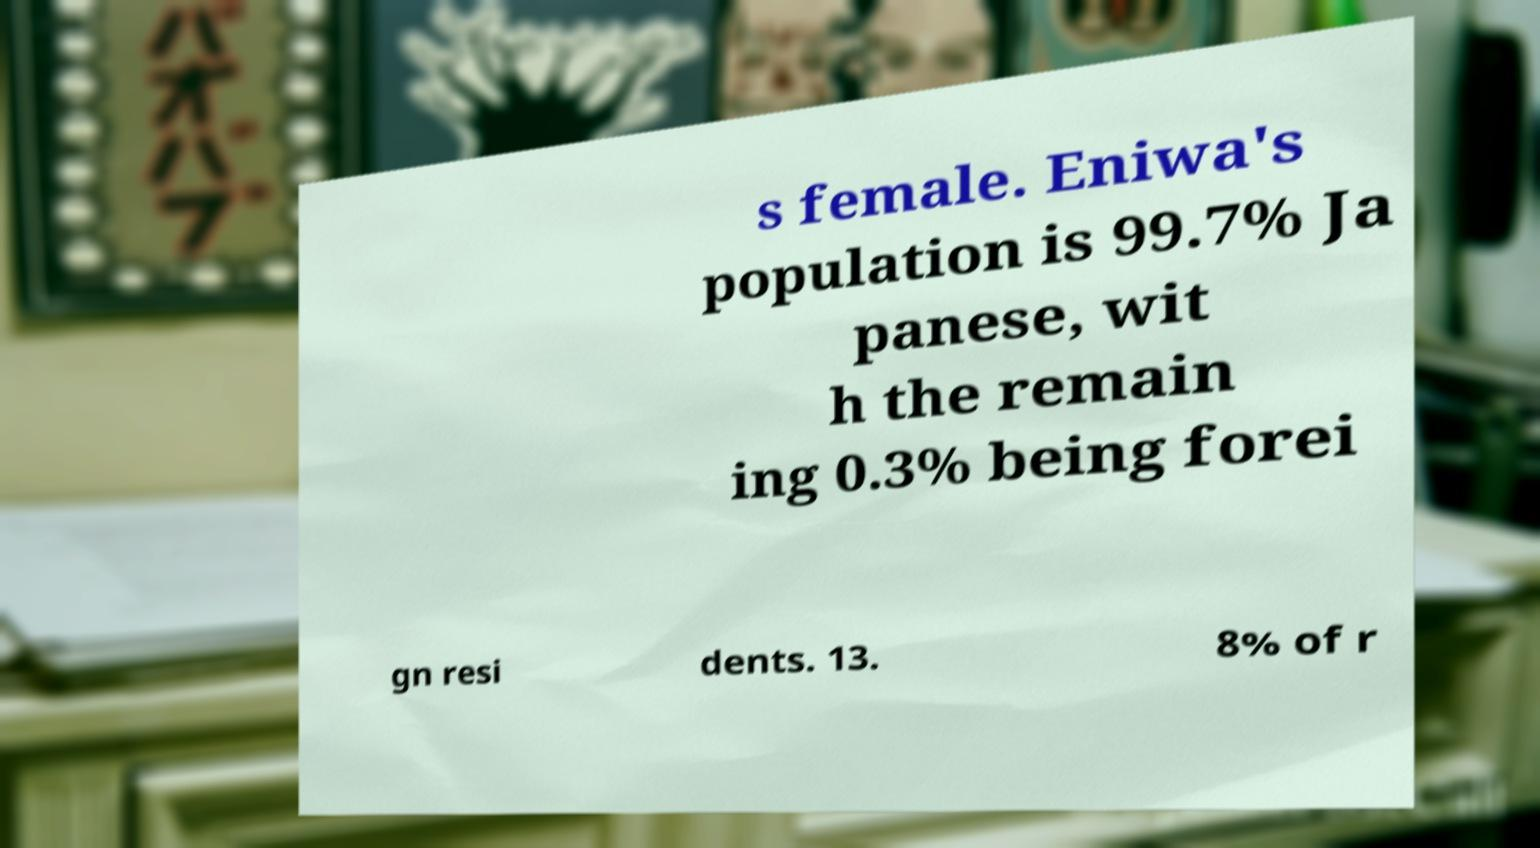There's text embedded in this image that I need extracted. Can you transcribe it verbatim? s female. Eniwa's population is 99.7% Ja panese, wit h the remain ing 0.3% being forei gn resi dents. 13. 8% of r 